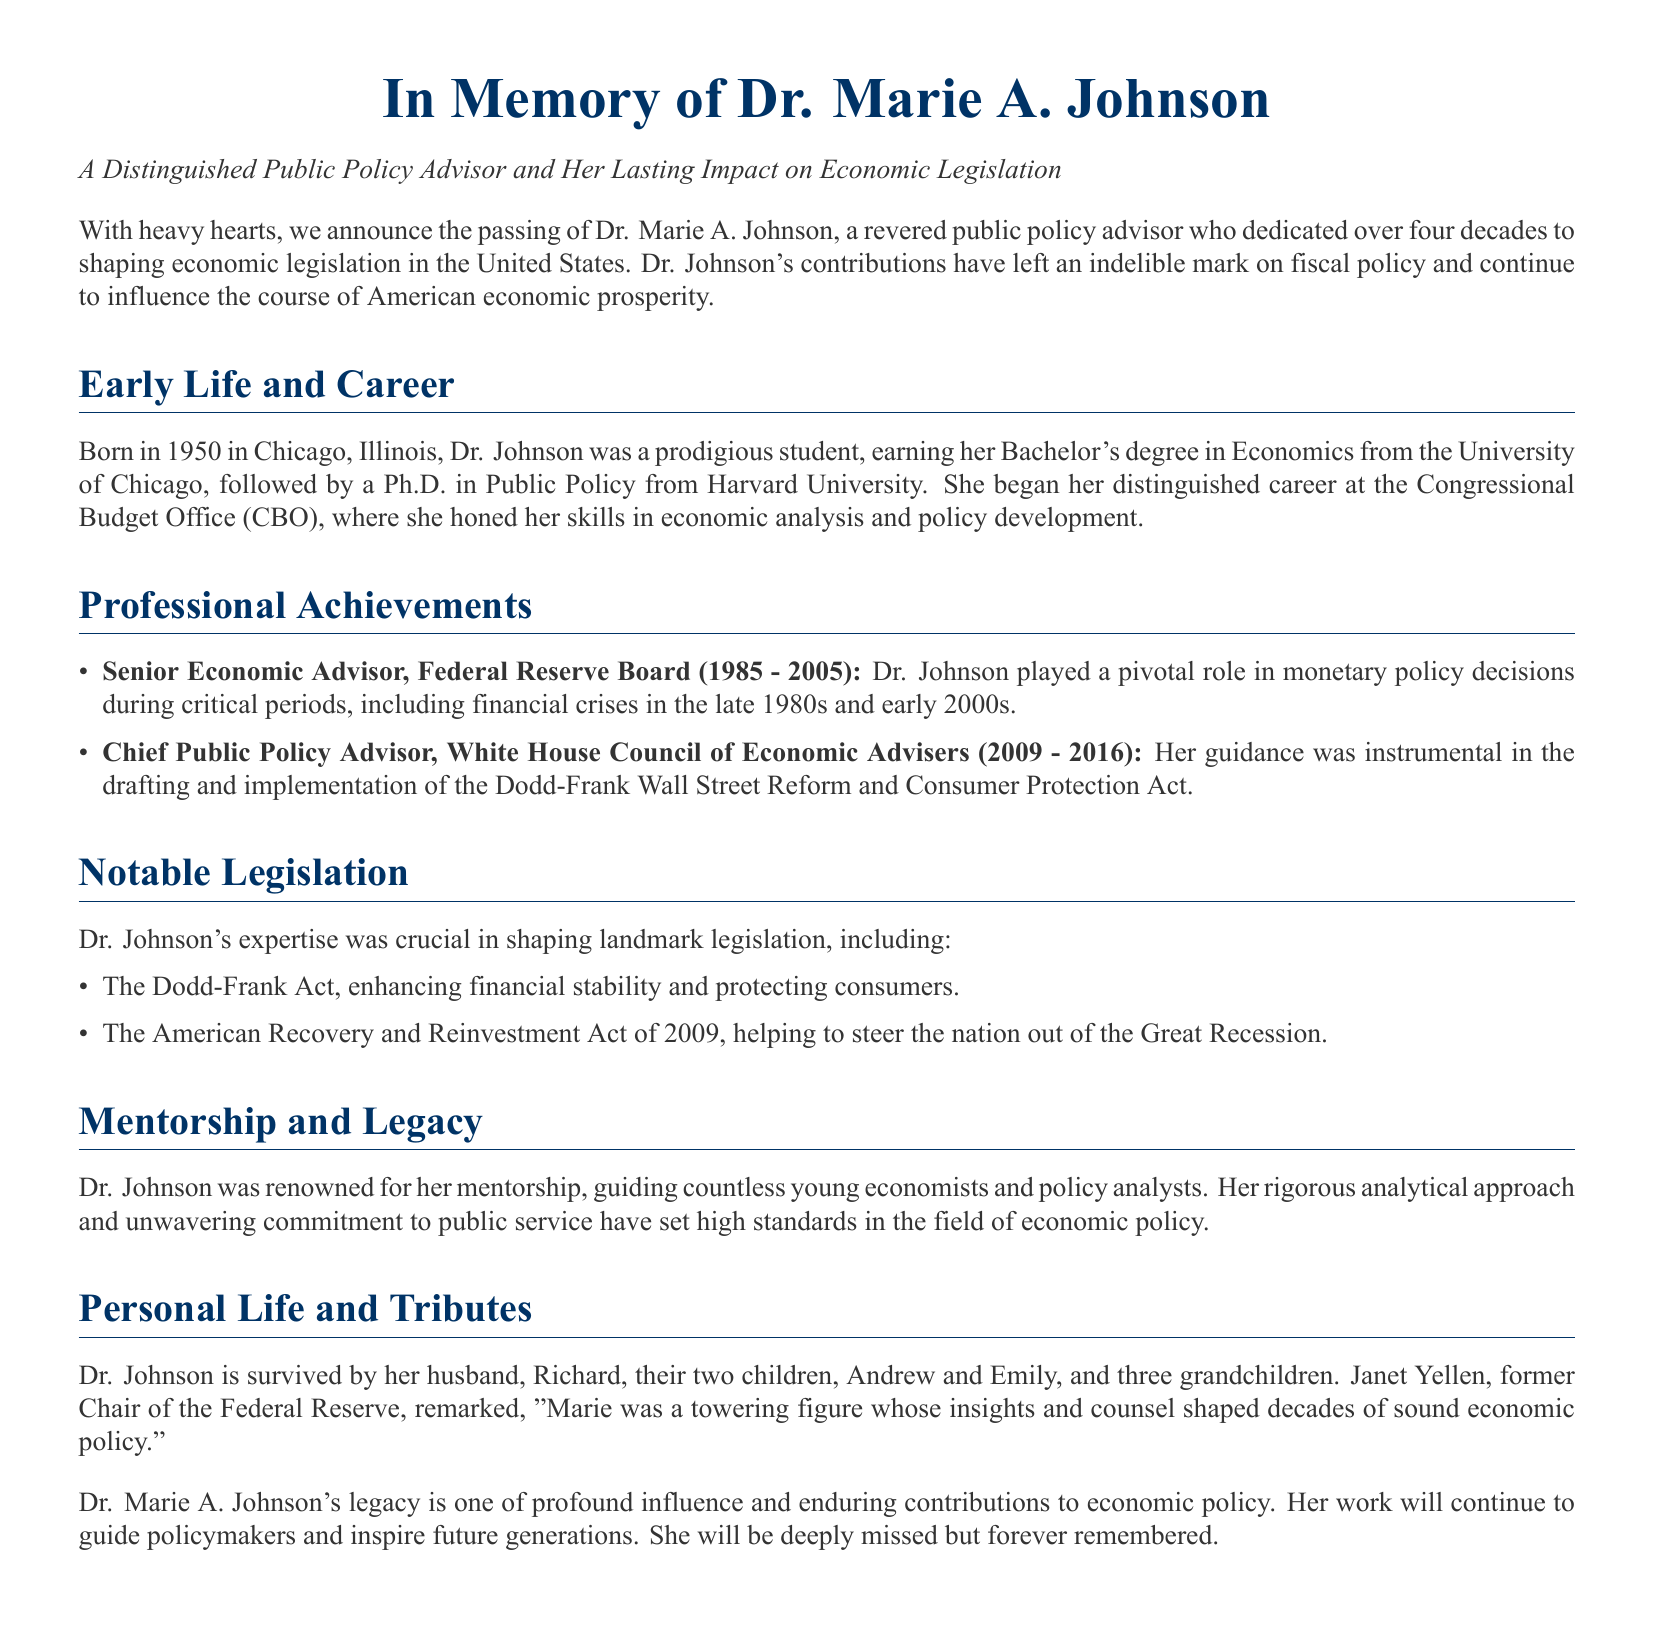What is the name of the distinguished public policy advisor? The document states the name of the advisor as Dr. Marie A. Johnson.
Answer: Dr. Marie A. Johnson In which year was Dr. Johnson born? According to the document, Dr. Johnson was born in the year 1950.
Answer: 1950 What degree did Dr. Johnson earn from the University of Chicago? The document mentions that she earned a Bachelor's degree in Economics.
Answer: Bachelor's degree in Economics Which two economic acts is Dr. Johnson noted for shaping? The document specifies the Dodd-Frank Act and the American Recovery and Reinvestment Act of 2009 as significant acts she shaped.
Answer: Dodd-Frank Act; American Recovery and Reinvestment Act of 2009 How many grandchildren did Dr. Johnson have? According to the document, Dr. Johnson is survived by three grandchildren.
Answer: three What period did Dr. Johnson serve as a Senior Economic Advisor at the Federal Reserve Board? The document indicates she served from 1985 to 2005.
Answer: 1985 - 2005 Which important act was implemented during Dr. Johnson's time at the White House Council of Economic Advisers? The document states that the Dodd-Frank Wall Street Reform and Consumer Protection Act was implemented during her time there.
Answer: Dodd-Frank Wall Street Reform and Consumer Protection Act Who made a tribute remark about Dr. Johnson in the document? The document mentions that Janet Yellen, former Chair of the Federal Reserve, made a remark about Dr. Johnson.
Answer: Janet Yellen What is a key aspect of Dr. Johnson's legacy mentioned in the document? The document highlights her mentorship in guiding young economists and her commitment to public service as key aspects of her legacy.
Answer: mentorship and commitment to public service 